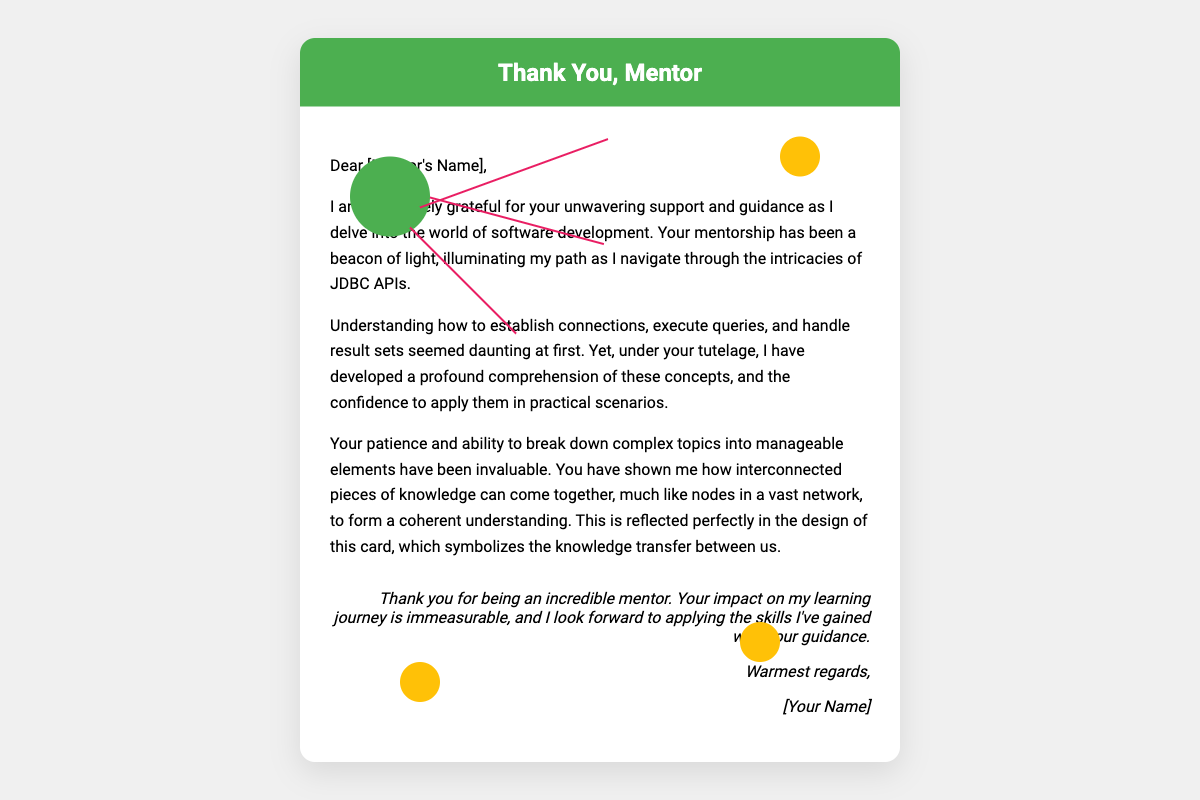What is the title of the card? The title of the card is prominently displayed at the top of the document.
Answer: Thank You, Mentor Who is the card intended for? The card is personalized with a greeting directed towards a specific individual.
Answer: [Mentor's Name] What color is used for the header background? The color used for the header background is specified in the style section of the document.
Answer: Green What is the main theme of the card? The overarching theme discussed in the message highlights the relationship between knowledge transfer and mentorship.
Answer: Gratitude How does the design symbolize the mentorship described? The interconnected nodes in the design represent the flow and connection of knowledge between mentor and mentee.
Answer: Knowledge transfer What type of APIs is mentioned in the content? The specific type of APIs referred to in the context of learning through mentorship is relevant to the individual's field.
Answer: JDBC APIs What does the writer express gratitude for? The writer acknowledges a specific aspect of the support received from the mentor in the learning process.
Answer: Unwavering support and guidance What is the closing sentiment expressed in the card? The last lines of the card reflect the writer's feeling towards the mentor and their hopes for future application of learned skills.
Answer: Thank you for being an incredible mentor What is the style of the closing message? The style of the closing message is a common way to sign off in personal and professional correspondence.
Answer: Warmest regards 